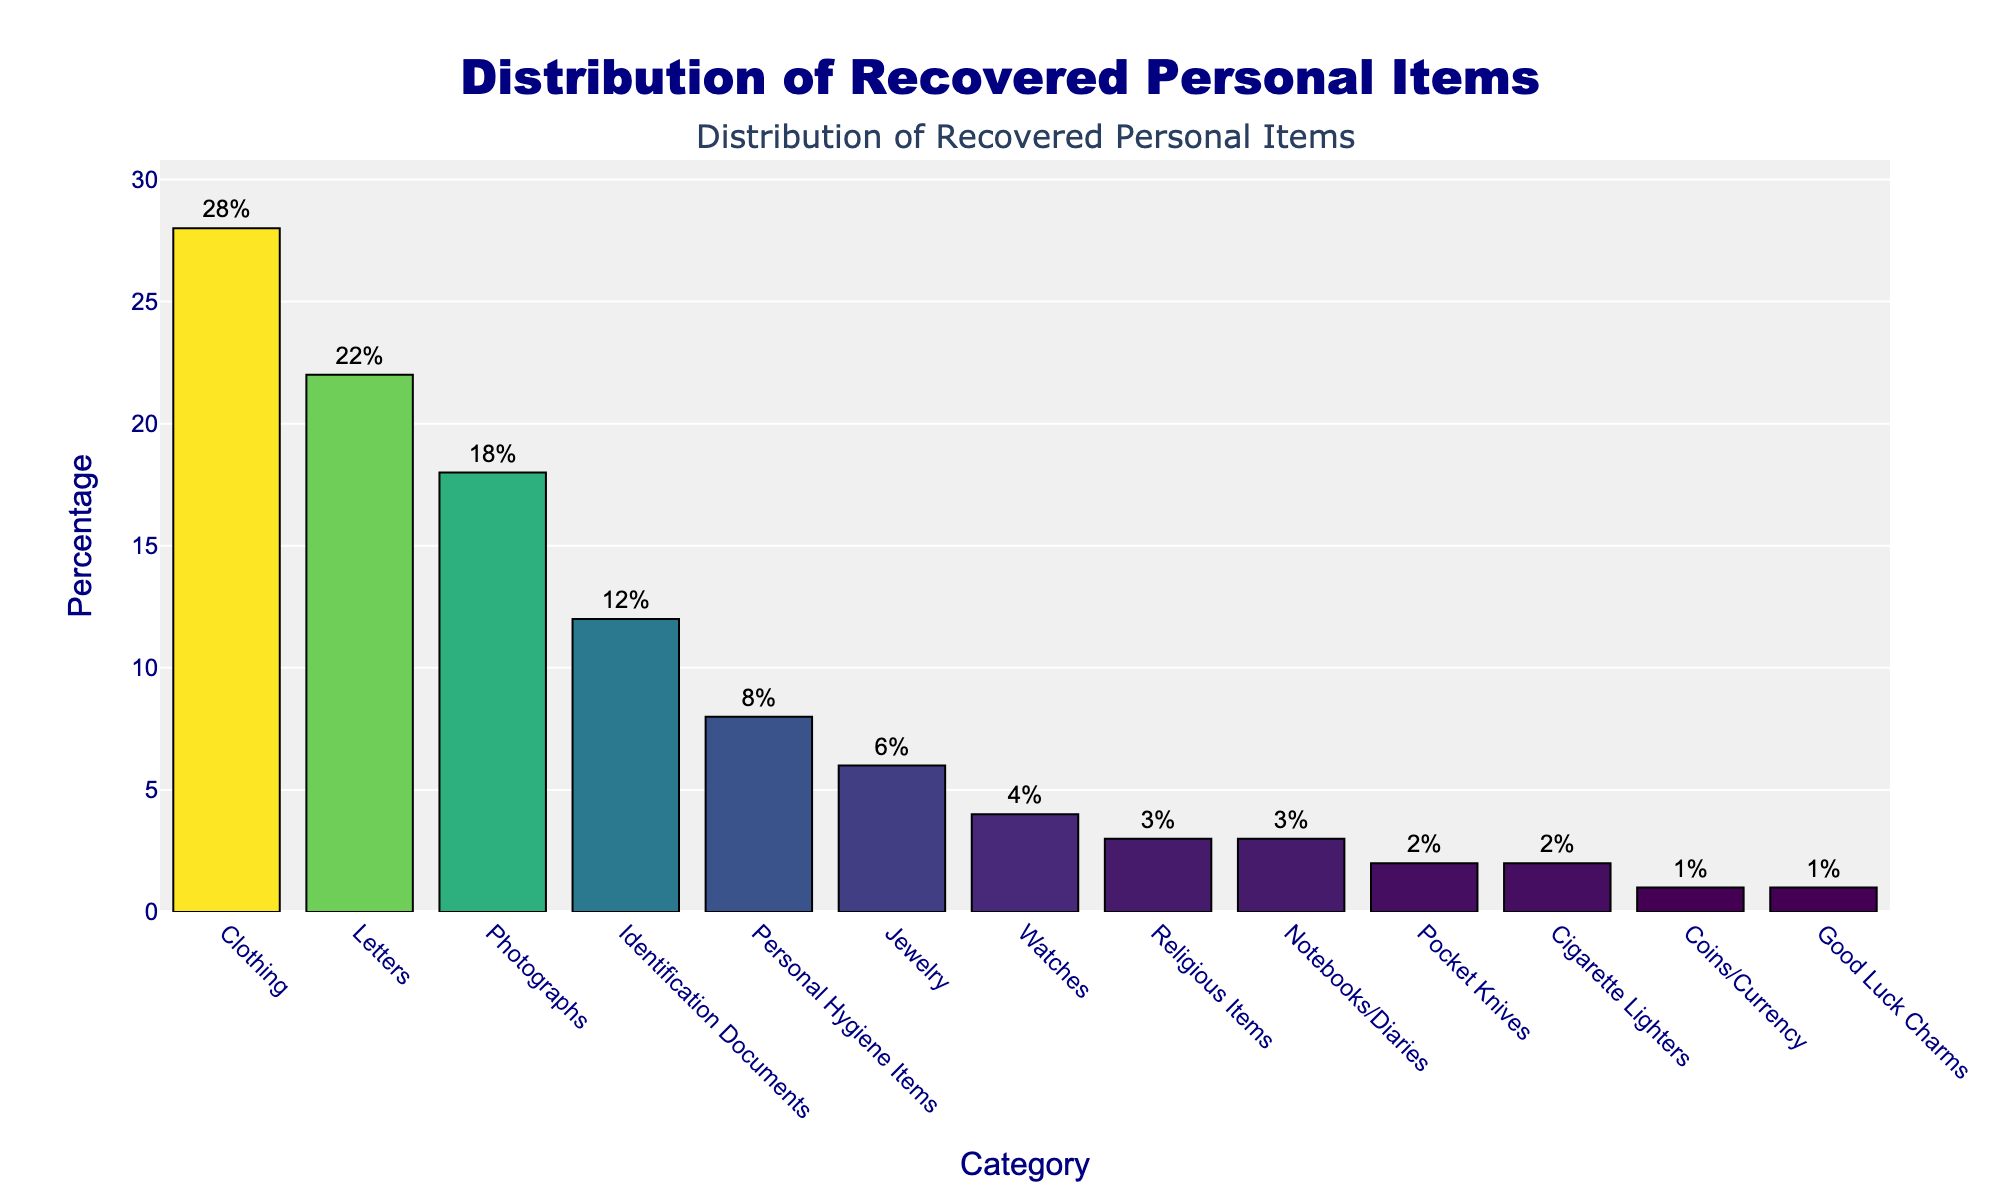Which category has the highest percentage of recovered items? The bar chart shows the percentage values of different categories. To find the category with the highest percentage, look for the tallest bar.
Answer: Clothing How does the percentage of recovered personal hygiene items compare to jewelry? Identify the bars for personal hygiene items and jewelry. Personal hygiene items have 8%, while jewelry has 6%.
Answer: Personal hygiene items have a higher percentage than jewelry What is the combined percentage of letters and photographs? Add the percentages of letters and photographs together: Letters (22%) + Photographs (18%) = 22% + 18% = 40%.
Answer: 40% Which categories have a percentage of 3% each? Look at the bars that reach the 3% mark on the y-axis. These categories are Religious Items and Notebooks/Diaries.
Answer: Religious Items and Notebooks/Diaries Are there more recovered letters or identification documents? Compare the bars for letters and identification documents. Letters are at 22%, and identification documents are at 12%.
Answer: More letters What's the percentage difference between coins/currency and cigarette lighters? Subtract the percentage of coins/currency (1%) from cigarette lighters (2%): 2% - 1% = 1%.
Answer: 1% Which category has the lowest percentage? Identify the shortest bar. The category is Good Luck Charms with 1%.
Answer: Good Luck Charms What is the average percentage of the top three categories? Add the percentages of the top three categories and divide by 3: (Clothing 28% + Letters 22% + Photographs 18%) / 3 = 68% / 3 ≈ 22.67%.
Answer: 22.67% How does the percentage of watches compare to the percentage of pocket knives? Compare the bars for watches (4%) and pocket knives (2%).
Answer: Watches have a higher percentage than pocket knives What is the combined percentage of items related to daily personal use (clothing, personal hygiene items, and cigarette lighters)? Add the percentages of clothing (28%), personal hygiene items (8%), and cigarette lighters (2%): 28% + 8% + 2% = 38%.
Answer: 38% 